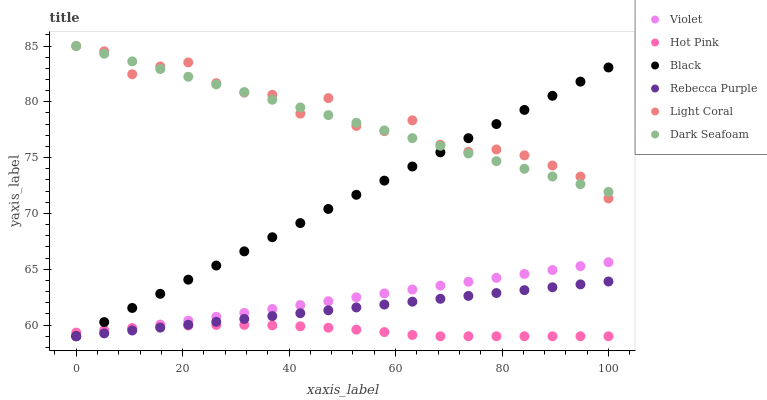Does Hot Pink have the minimum area under the curve?
Answer yes or no. Yes. Does Light Coral have the maximum area under the curve?
Answer yes or no. Yes. Does Dark Seafoam have the minimum area under the curve?
Answer yes or no. No. Does Dark Seafoam have the maximum area under the curve?
Answer yes or no. No. Is Rebecca Purple the smoothest?
Answer yes or no. Yes. Is Light Coral the roughest?
Answer yes or no. Yes. Is Dark Seafoam the smoothest?
Answer yes or no. No. Is Dark Seafoam the roughest?
Answer yes or no. No. Does Hot Pink have the lowest value?
Answer yes or no. Yes. Does Light Coral have the lowest value?
Answer yes or no. No. Does Dark Seafoam have the highest value?
Answer yes or no. Yes. Does Black have the highest value?
Answer yes or no. No. Is Violet less than Dark Seafoam?
Answer yes or no. Yes. Is Light Coral greater than Violet?
Answer yes or no. Yes. Does Black intersect Light Coral?
Answer yes or no. Yes. Is Black less than Light Coral?
Answer yes or no. No. Is Black greater than Light Coral?
Answer yes or no. No. Does Violet intersect Dark Seafoam?
Answer yes or no. No. 